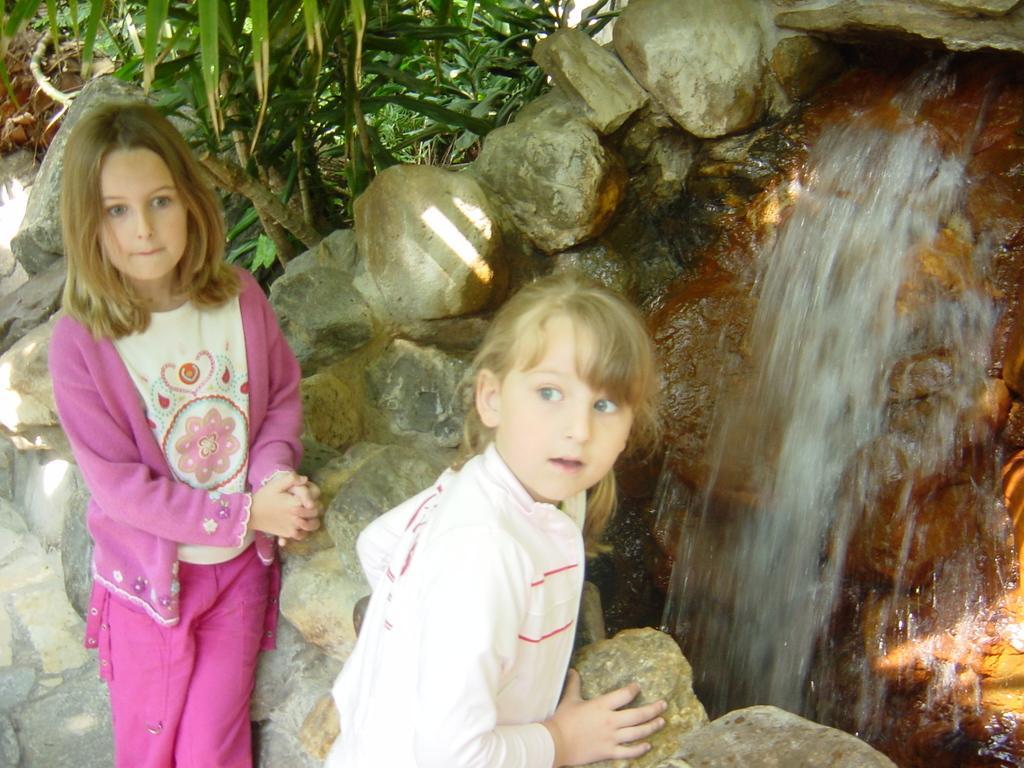Please provide a concise description of this image. In this image we can see two kids. In the background there is a fountain and we can see rocks. There are trees. 